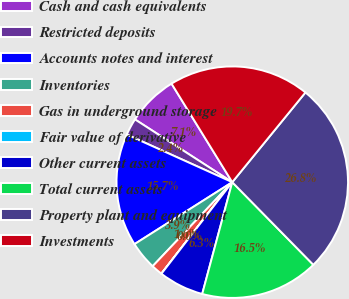Convert chart to OTSL. <chart><loc_0><loc_0><loc_500><loc_500><pie_chart><fcel>Cash and cash equivalents<fcel>Restricted deposits<fcel>Accounts notes and interest<fcel>Inventories<fcel>Gas in underground storage<fcel>Fair value of derivative<fcel>Other current assets<fcel>Total current assets<fcel>Property plant and equipment<fcel>Investments<nl><fcel>7.09%<fcel>2.37%<fcel>15.74%<fcel>3.94%<fcel>1.58%<fcel>0.01%<fcel>6.3%<fcel>16.53%<fcel>26.76%<fcel>19.68%<nl></chart> 